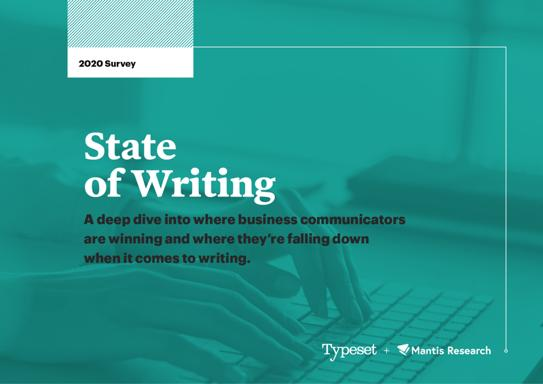Based on the survey, what are some common challenges faced by business communicators? This survey identifies several key challenges, including issues with clarity, maintaining a consistent tone, and effectively engaging the target audience. These areas significantly impact the overall effectiveness of business communication according to the results depicted in the image. 